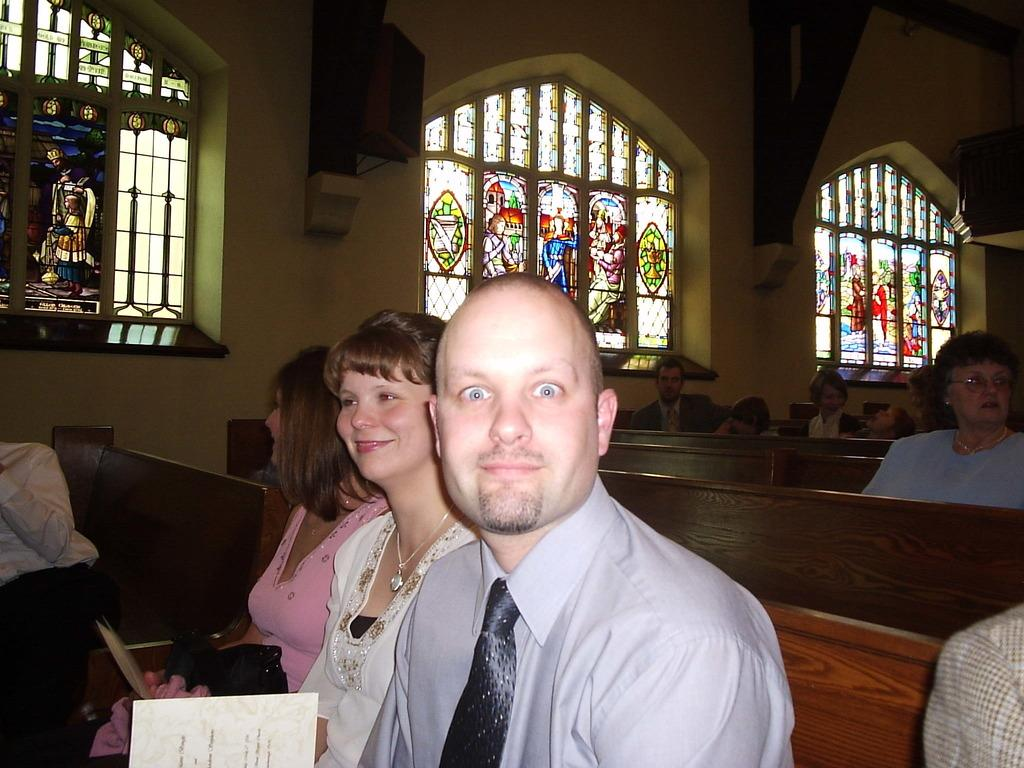What are the people in the image doing? The people in the image are sitting on benches. What is located at the bottom of the image? There are cards at the bottom of the image. What can be seen in the background of the image? There are windows and stained glasses in the background of the image. What is the main structure in the image? There is a wall in the image. What is the name of the farmer in the image? There is no farmer present in the image. What surprises the people sitting on the benches in the image? The image does not provide information about any surprises or unexpected events. 